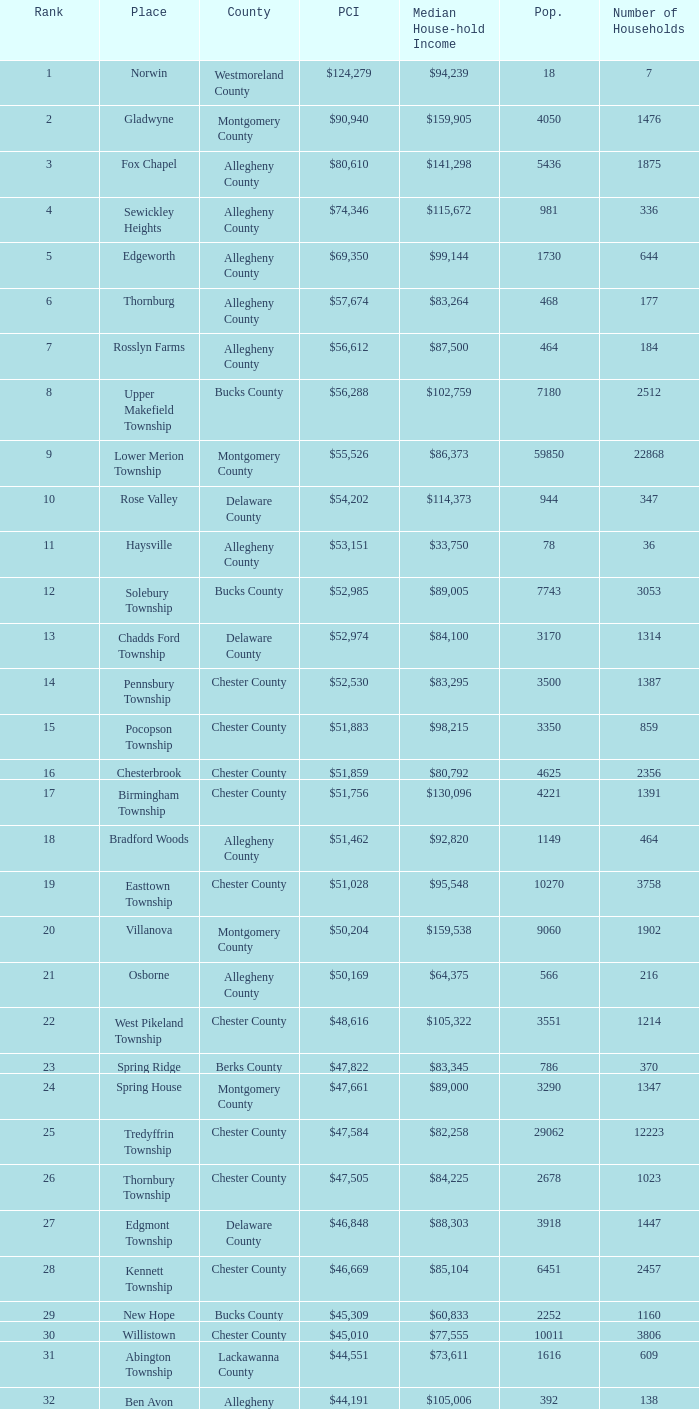What is the median household income for Woodside? $121,151. 